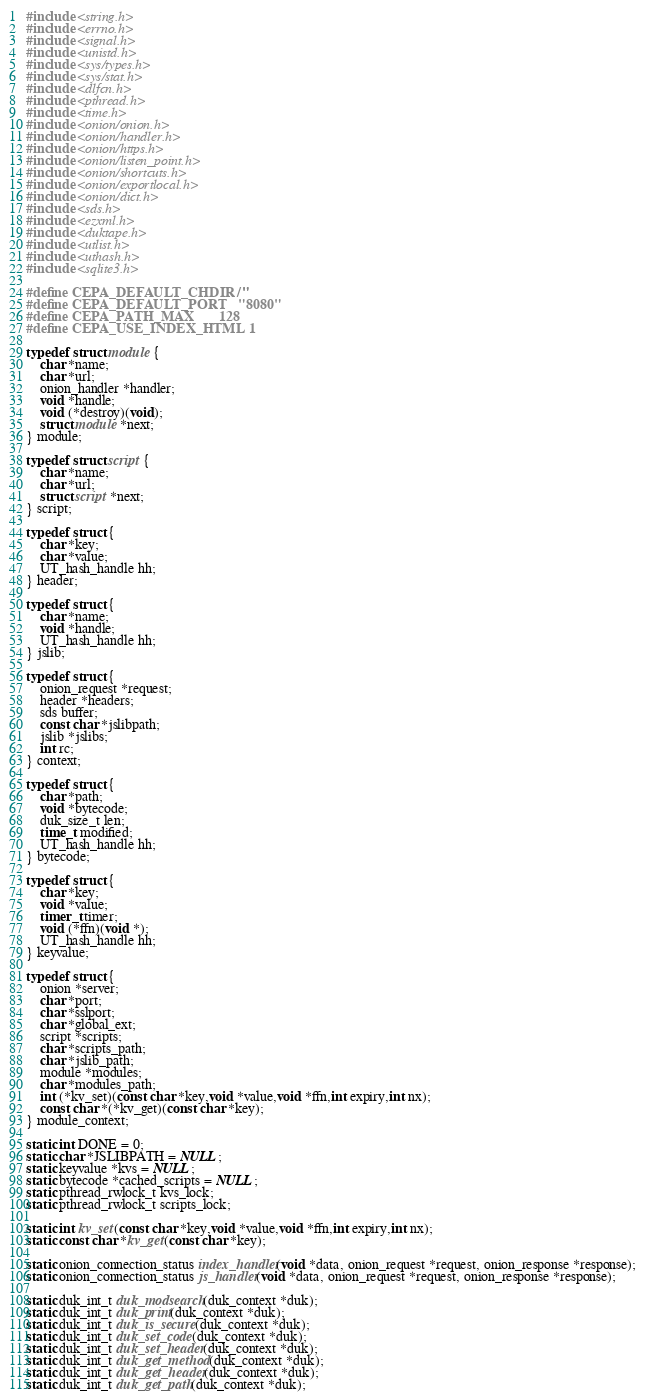<code> <loc_0><loc_0><loc_500><loc_500><_C_>#include <string.h>
#include <errno.h>
#include <signal.h>
#include <unistd.h>
#include <sys/types.h>
#include <sys/stat.h>
#include <dlfcn.h>
#include <pthread.h>
#include <time.h>
#include <onion/onion.h>
#include <onion/handler.h>
#include <onion/https.h>
#include <onion/listen_point.h>
#include <onion/shortcuts.h>
#include <onion/exportlocal.h>
#include <onion/dict.h>
#include <sds.h>
#include <ezxml.h>
#include <duktape.h>
#include <utlist.h>
#include <uthash.h>
#include <sqlite3.h>

#define CEPA_DEFAULT_CHDIR  "/"
#define CEPA_DEFAULT_PORT   "8080"
#define CEPA_PATH_MAX       128
#define CEPA_USE_INDEX_HTML 1

typedef struct module {
	char *name;
	char *url;
	onion_handler *handler;
	void *handle;
	void (*destroy)(void);
	struct module *next;
} module;

typedef struct script {
	char *name;
	char *url;
	struct script *next;
} script;

typedef struct {
	char *key;
	char *value;
	UT_hash_handle hh;
} header;

typedef struct {
	char *name;
	void *handle;
	UT_hash_handle hh;
} jslib;

typedef struct {
	onion_request *request;
	header *headers;
	sds buffer;
	const char *jslibpath;
	jslib *jslibs;
	int rc;
} context;

typedef struct {
	char *path;
	void *bytecode;
	duk_size_t len;
	time_t modified;
	UT_hash_handle hh;
} bytecode;

typedef struct {
	char *key;
	void *value;
	timer_t timer;
	void (*ffn)(void *);
	UT_hash_handle hh;
} keyvalue;

typedef struct {
	onion *server;
	char *port;
	char *sslport;
	char *global_ext;
	script *scripts;
	char *scripts_path;
	char *jslib_path;
	module *modules;
	char *modules_path;
	int (*kv_set)(const char *key,void *value,void *ffn,int expiry,int nx);
	const char *(*kv_get)(const char *key);
} module_context;

static int DONE = 0;
static char *JSLIBPATH = NULL;
static keyvalue *kvs = NULL;
static bytecode *cached_scripts = NULL;
static pthread_rwlock_t kvs_lock;
static pthread_rwlock_t scripts_lock;

static int kv_set(const char *key,void *value,void *ffn,int expiry,int nx);
static const char *kv_get(const char *key);

static onion_connection_status index_handler(void *data, onion_request *request, onion_response *response);
static onion_connection_status js_handler(void *data, onion_request *request, onion_response *response);

static duk_int_t duk_modsearch(duk_context *duk);
static duk_int_t duk_print(duk_context *duk);
static duk_int_t duk_is_secure(duk_context *duk);
static duk_int_t duk_set_code(duk_context *duk);
static duk_int_t duk_set_header(duk_context *duk);
static duk_int_t duk_get_method(duk_context *duk);
static duk_int_t duk_get_header(duk_context *duk);
static duk_int_t duk_get_path(duk_context *duk);</code> 